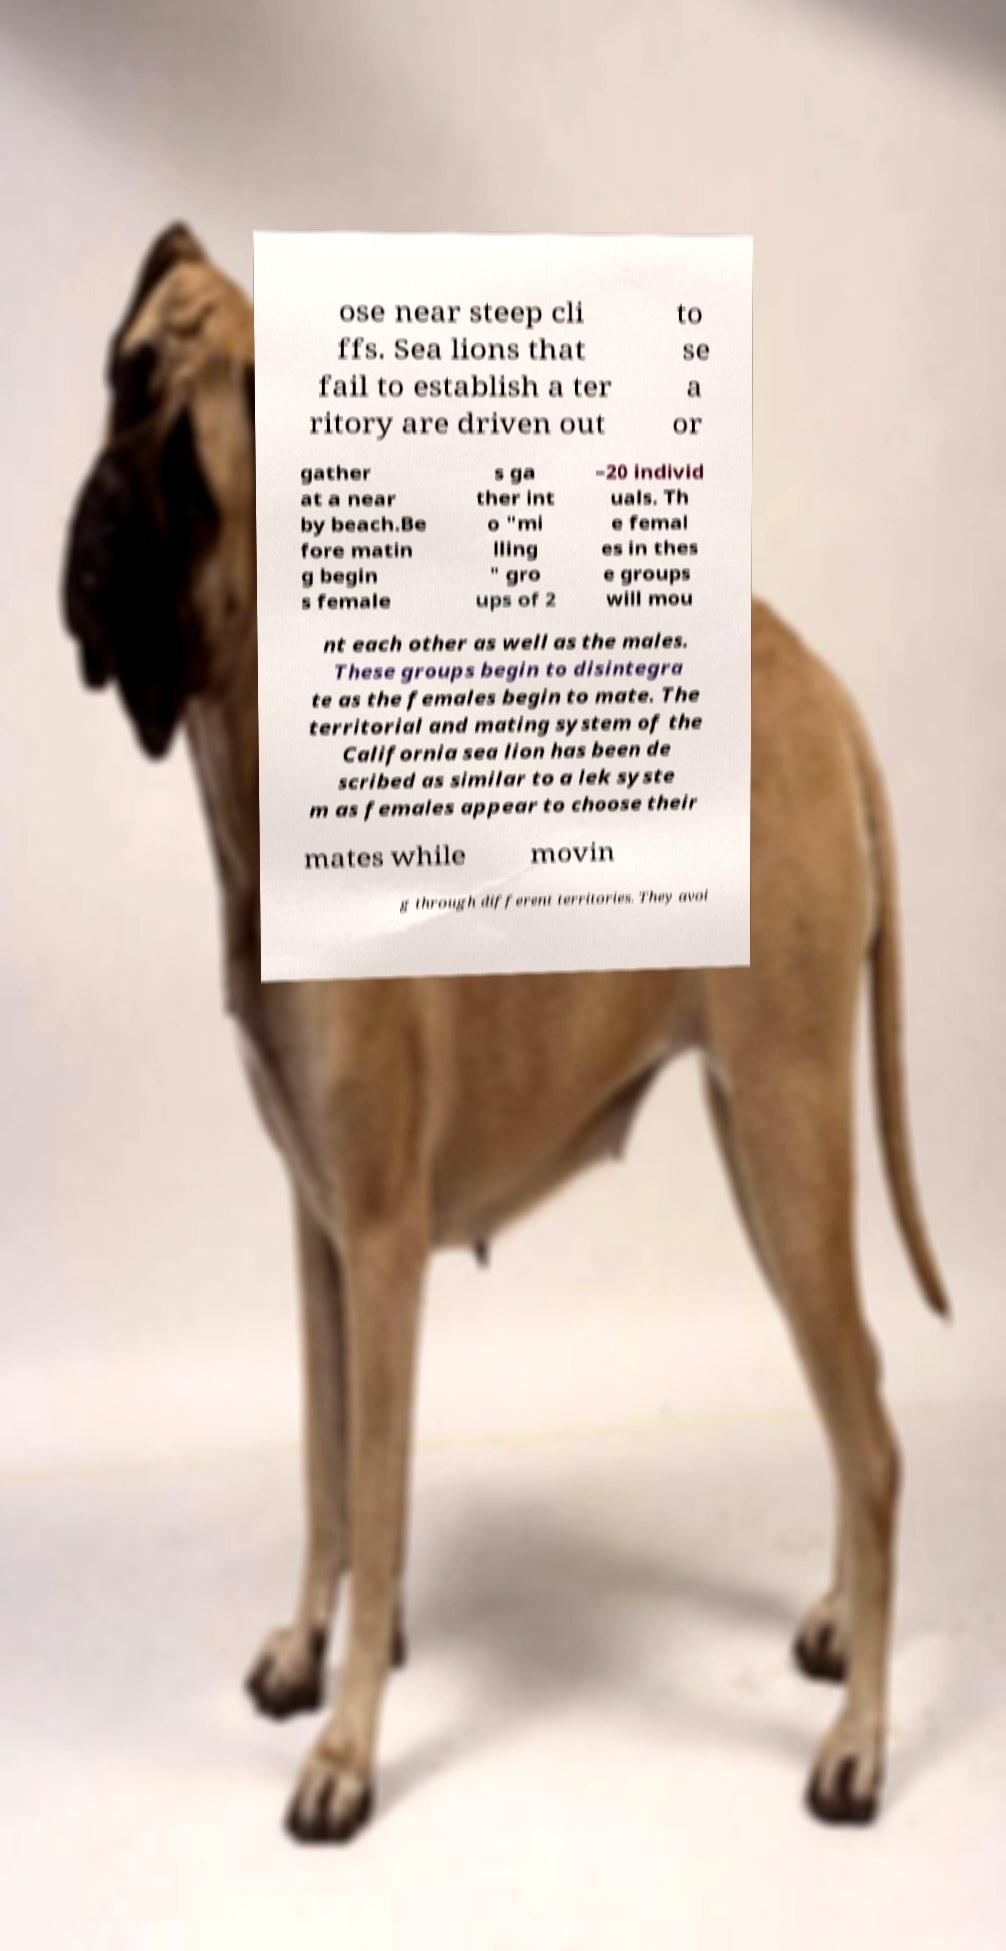There's text embedded in this image that I need extracted. Can you transcribe it verbatim? ose near steep cli ffs. Sea lions that fail to establish a ter ritory are driven out to se a or gather at a near by beach.Be fore matin g begin s female s ga ther int o "mi lling " gro ups of 2 –20 individ uals. Th e femal es in thes e groups will mou nt each other as well as the males. These groups begin to disintegra te as the females begin to mate. The territorial and mating system of the California sea lion has been de scribed as similar to a lek syste m as females appear to choose their mates while movin g through different territories. They avoi 